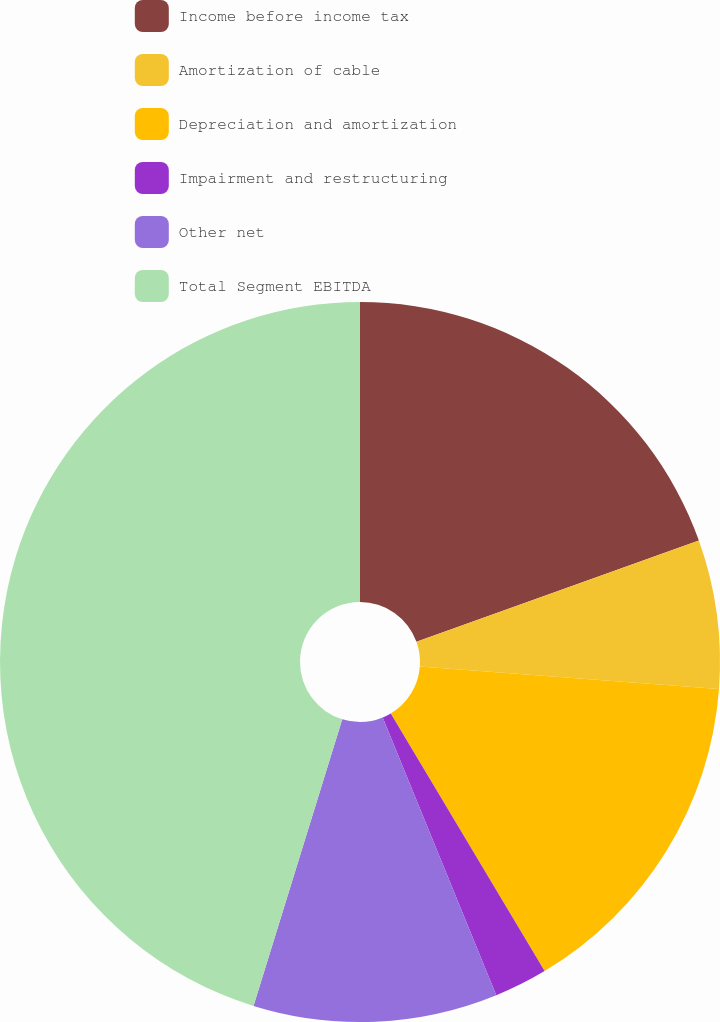<chart> <loc_0><loc_0><loc_500><loc_500><pie_chart><fcel>Income before income tax<fcel>Amortization of cable<fcel>Depreciation and amortization<fcel>Impairment and restructuring<fcel>Other net<fcel>Total Segment EBITDA<nl><fcel>19.52%<fcel>6.67%<fcel>15.24%<fcel>2.39%<fcel>10.96%<fcel>45.22%<nl></chart> 